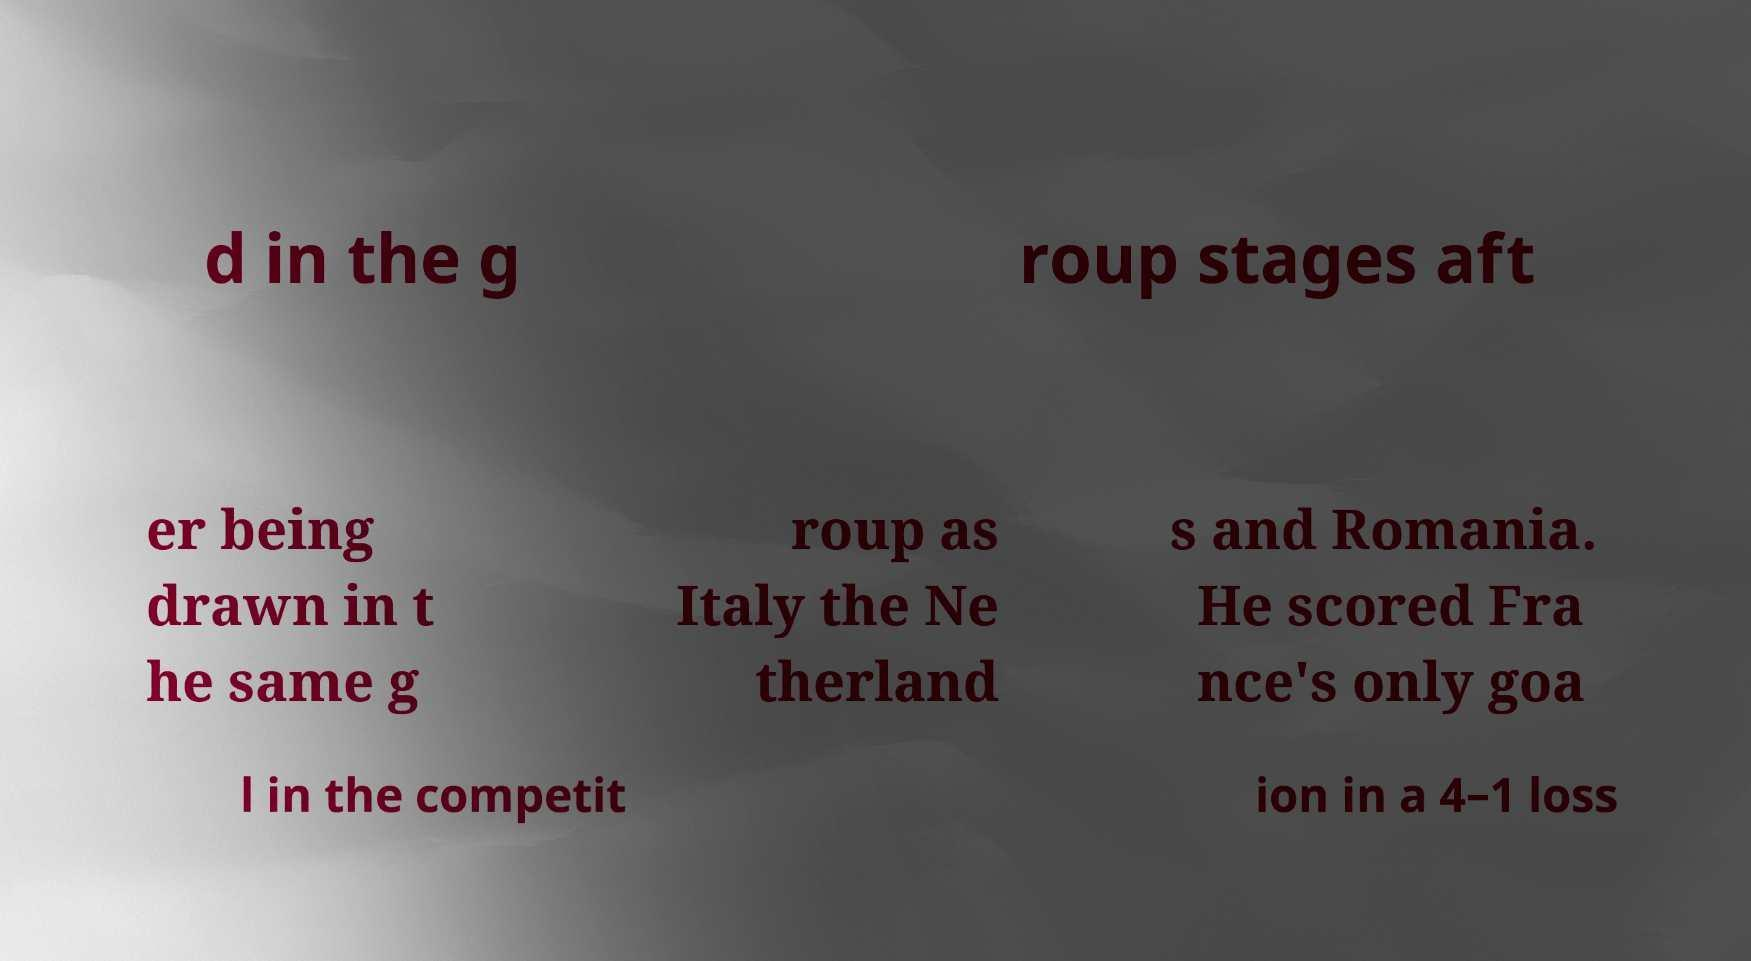I need the written content from this picture converted into text. Can you do that? d in the g roup stages aft er being drawn in t he same g roup as Italy the Ne therland s and Romania. He scored Fra nce's only goa l in the competit ion in a 4–1 loss 